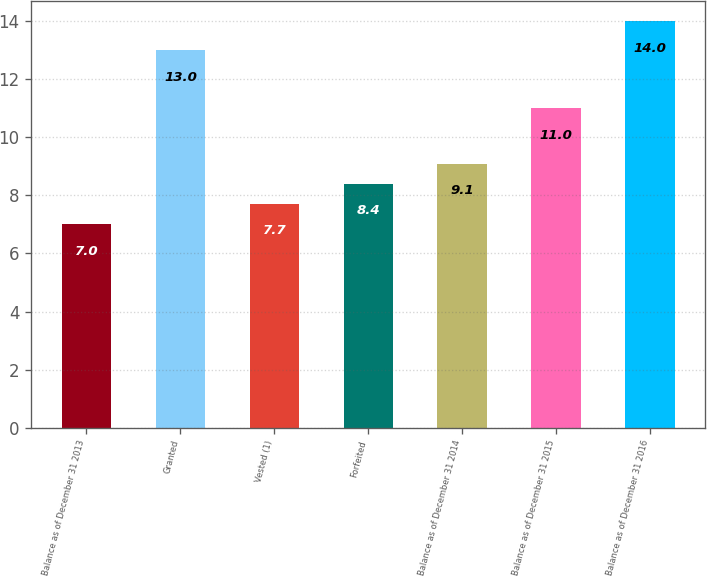Convert chart to OTSL. <chart><loc_0><loc_0><loc_500><loc_500><bar_chart><fcel>Balance as of December 31 2013<fcel>Granted<fcel>Vested (1)<fcel>Forfeited<fcel>Balance as of December 31 2014<fcel>Balance as of December 31 2015<fcel>Balance as of December 31 2016<nl><fcel>7<fcel>13<fcel>7.7<fcel>8.4<fcel>9.1<fcel>11<fcel>14<nl></chart> 